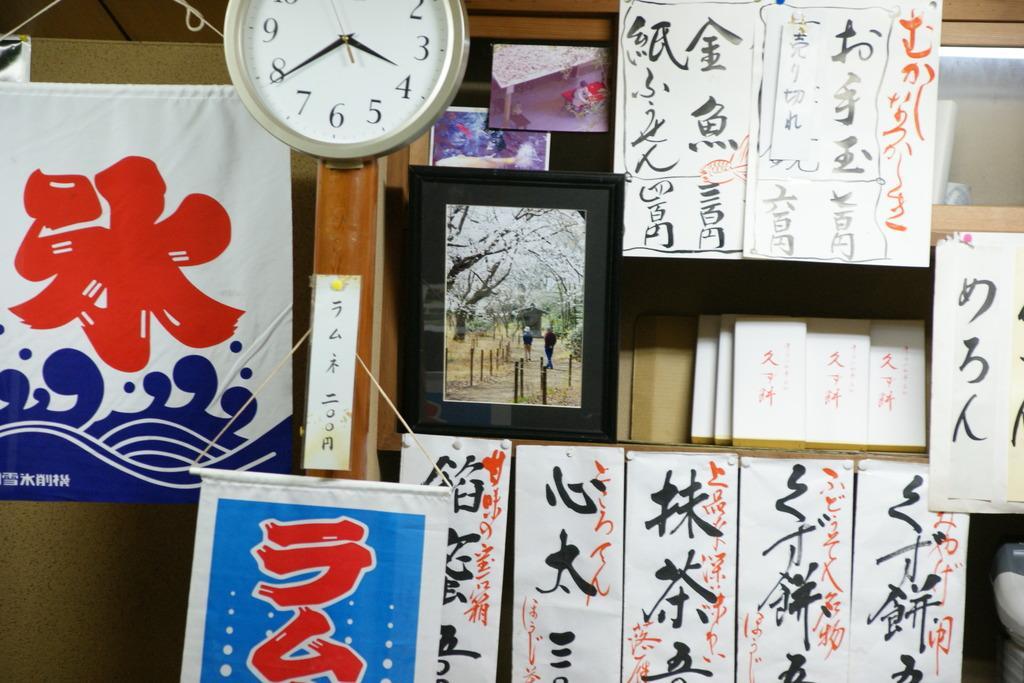How would you summarize this image in a sentence or two? In the image there are photo frames,watch,scriptures,books on the wall and on the shelves. 